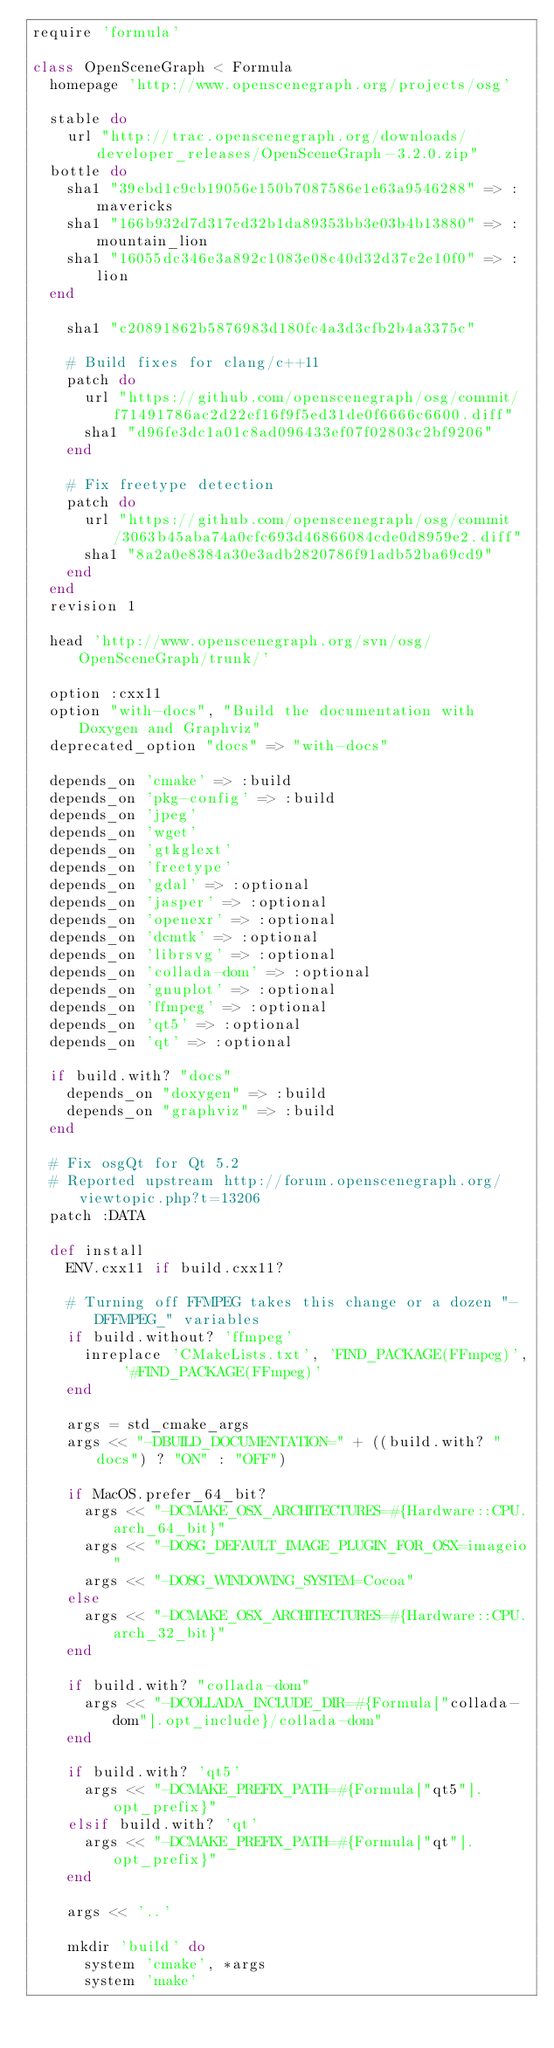Convert code to text. <code><loc_0><loc_0><loc_500><loc_500><_Ruby_>require 'formula'

class OpenSceneGraph < Formula
  homepage 'http://www.openscenegraph.org/projects/osg'

  stable do
    url "http://trac.openscenegraph.org/downloads/developer_releases/OpenSceneGraph-3.2.0.zip"
  bottle do
    sha1 "39ebd1c9cb19056e150b7087586e1e63a9546288" => :mavericks
    sha1 "166b932d7d317cd32b1da89353bb3e03b4b13880" => :mountain_lion
    sha1 "16055dc346e3a892c1083e08c40d32d37c2e10f0" => :lion
  end

    sha1 "c20891862b5876983d180fc4a3d3cfb2b4a3375c"

    # Build fixes for clang/c++11
    patch do
      url "https://github.com/openscenegraph/osg/commit/f71491786ac2d22ef16f9f5ed31de0f6666c6600.diff"
      sha1 "d96fe3dc1a01c8ad096433ef07f02803c2bf9206"
    end

    # Fix freetype detection
    patch do
      url "https://github.com/openscenegraph/osg/commit/3063b45aba74a0cfc693d46866084cde0d8959e2.diff"
      sha1 "8a2a0e8384a30e3adb2820786f91adb52ba69cd9"
    end
  end
  revision 1

  head 'http://www.openscenegraph.org/svn/osg/OpenSceneGraph/trunk/'

  option :cxx11
  option "with-docs", "Build the documentation with Doxygen and Graphviz"
  deprecated_option "docs" => "with-docs"

  depends_on 'cmake' => :build
  depends_on 'pkg-config' => :build
  depends_on 'jpeg'
  depends_on 'wget'
  depends_on 'gtkglext'
  depends_on 'freetype'
  depends_on 'gdal' => :optional
  depends_on 'jasper' => :optional
  depends_on 'openexr' => :optional
  depends_on 'dcmtk' => :optional
  depends_on 'librsvg' => :optional
  depends_on 'collada-dom' => :optional
  depends_on 'gnuplot' => :optional
  depends_on 'ffmpeg' => :optional
  depends_on 'qt5' => :optional
  depends_on 'qt' => :optional

  if build.with? "docs"
    depends_on "doxygen" => :build
    depends_on "graphviz" => :build
  end

  # Fix osgQt for Qt 5.2
  # Reported upstream http://forum.openscenegraph.org/viewtopic.php?t=13206
  patch :DATA

  def install
    ENV.cxx11 if build.cxx11?

    # Turning off FFMPEG takes this change or a dozen "-DFFMPEG_" variables
    if build.without? 'ffmpeg'
      inreplace 'CMakeLists.txt', 'FIND_PACKAGE(FFmpeg)', '#FIND_PACKAGE(FFmpeg)'
    end

    args = std_cmake_args
    args << "-DBUILD_DOCUMENTATION=" + ((build.with? "docs") ? "ON" : "OFF")

    if MacOS.prefer_64_bit?
      args << "-DCMAKE_OSX_ARCHITECTURES=#{Hardware::CPU.arch_64_bit}"
      args << "-DOSG_DEFAULT_IMAGE_PLUGIN_FOR_OSX=imageio"
      args << "-DOSG_WINDOWING_SYSTEM=Cocoa"
    else
      args << "-DCMAKE_OSX_ARCHITECTURES=#{Hardware::CPU.arch_32_bit}"
    end

    if build.with? "collada-dom"
      args << "-DCOLLADA_INCLUDE_DIR=#{Formula["collada-dom"].opt_include}/collada-dom"
    end

    if build.with? 'qt5'
      args << "-DCMAKE_PREFIX_PATH=#{Formula["qt5"].opt_prefix}"
    elsif build.with? 'qt'
      args << "-DCMAKE_PREFIX_PATH=#{Formula["qt"].opt_prefix}"
    end

    args << '..'

    mkdir 'build' do
      system 'cmake', *args
      system 'make'</code> 